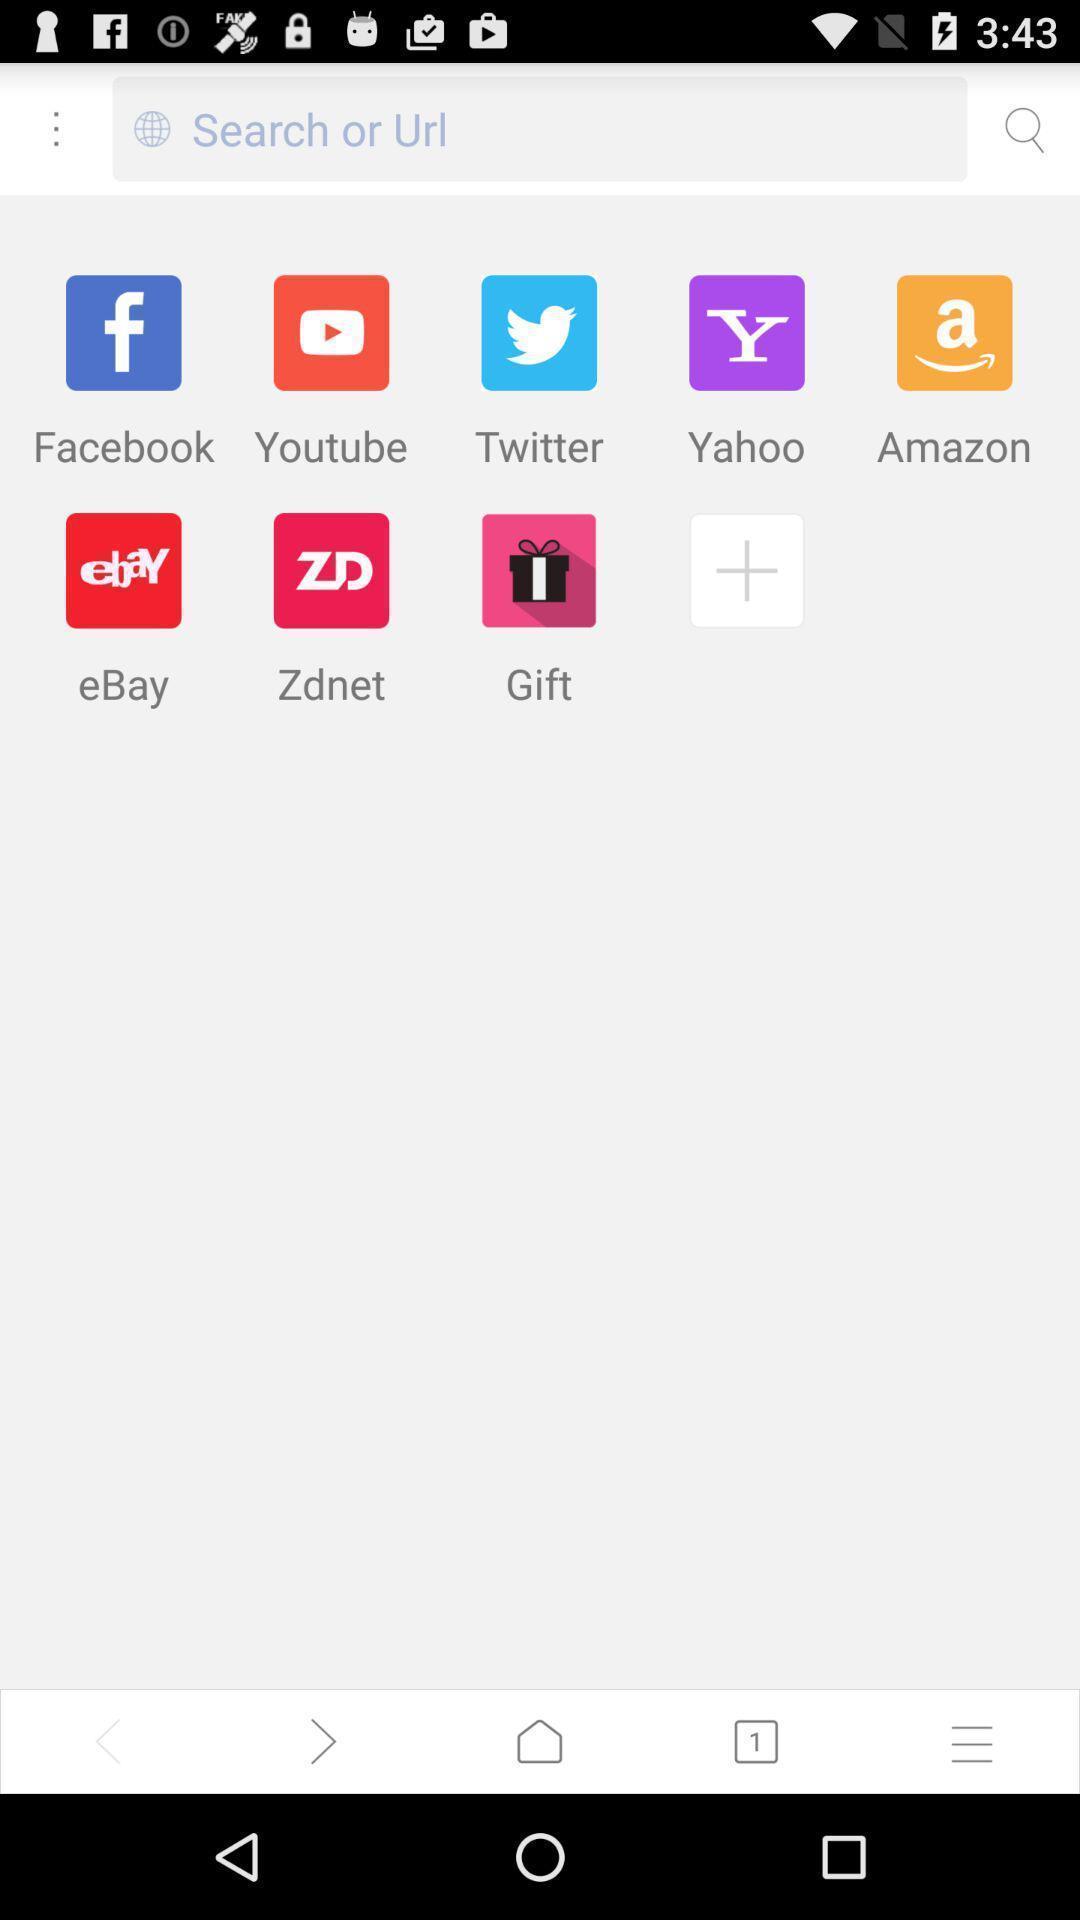Please provide a description for this image. Screen showing search bar with applications. 